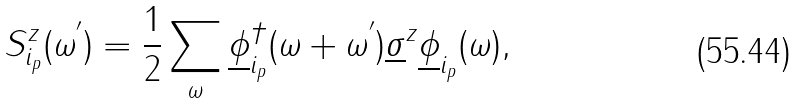Convert formula to latex. <formula><loc_0><loc_0><loc_500><loc_500>S _ { i _ { p } } ^ { z } ( \omega ^ { ^ { \prime } } ) = \frac { 1 } { 2 } \sum _ { \omega } \underline { \phi } ^ { \dagger } _ { i _ { p } } ( \omega + \omega ^ { ^ { \prime } } ) \underline { \sigma } ^ { z } \underline { \phi } _ { i _ { p } } ( \omega ) ,</formula> 